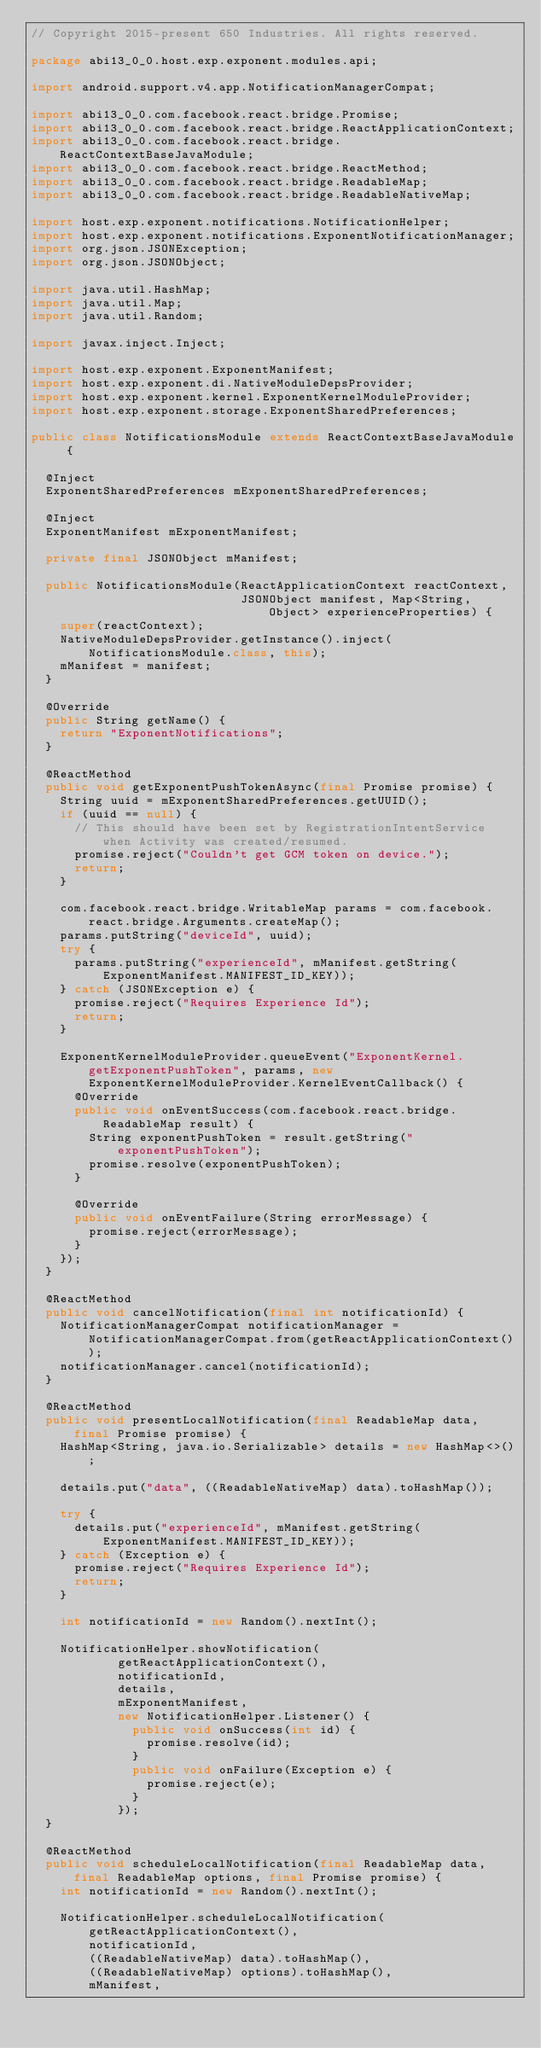Convert code to text. <code><loc_0><loc_0><loc_500><loc_500><_Java_>// Copyright 2015-present 650 Industries. All rights reserved.

package abi13_0_0.host.exp.exponent.modules.api;

import android.support.v4.app.NotificationManagerCompat;

import abi13_0_0.com.facebook.react.bridge.Promise;
import abi13_0_0.com.facebook.react.bridge.ReactApplicationContext;
import abi13_0_0.com.facebook.react.bridge.ReactContextBaseJavaModule;
import abi13_0_0.com.facebook.react.bridge.ReactMethod;
import abi13_0_0.com.facebook.react.bridge.ReadableMap;
import abi13_0_0.com.facebook.react.bridge.ReadableNativeMap;

import host.exp.exponent.notifications.NotificationHelper;
import host.exp.exponent.notifications.ExponentNotificationManager;
import org.json.JSONException;
import org.json.JSONObject;

import java.util.HashMap;
import java.util.Map;
import java.util.Random;

import javax.inject.Inject;

import host.exp.exponent.ExponentManifest;
import host.exp.exponent.di.NativeModuleDepsProvider;
import host.exp.exponent.kernel.ExponentKernelModuleProvider;
import host.exp.exponent.storage.ExponentSharedPreferences;

public class NotificationsModule extends ReactContextBaseJavaModule {

  @Inject
  ExponentSharedPreferences mExponentSharedPreferences;

  @Inject
  ExponentManifest mExponentManifest;

  private final JSONObject mManifest;

  public NotificationsModule(ReactApplicationContext reactContext,
                             JSONObject manifest, Map<String, Object> experienceProperties) {
    super(reactContext);
    NativeModuleDepsProvider.getInstance().inject(NotificationsModule.class, this);
    mManifest = manifest;
  }

  @Override
  public String getName() {
    return "ExponentNotifications";
  }

  @ReactMethod
  public void getExponentPushTokenAsync(final Promise promise) {
    String uuid = mExponentSharedPreferences.getUUID();
    if (uuid == null) {
      // This should have been set by RegistrationIntentService when Activity was created/resumed.
      promise.reject("Couldn't get GCM token on device.");
      return;
    }

    com.facebook.react.bridge.WritableMap params = com.facebook.react.bridge.Arguments.createMap();
    params.putString("deviceId", uuid);
    try {
      params.putString("experienceId", mManifest.getString(ExponentManifest.MANIFEST_ID_KEY));
    } catch (JSONException e) {
      promise.reject("Requires Experience Id");
      return;
    }

    ExponentKernelModuleProvider.queueEvent("ExponentKernel.getExponentPushToken", params, new ExponentKernelModuleProvider.KernelEventCallback() {
      @Override
      public void onEventSuccess(com.facebook.react.bridge.ReadableMap result) {
        String exponentPushToken = result.getString("exponentPushToken");
        promise.resolve(exponentPushToken);
      }

      @Override
      public void onEventFailure(String errorMessage) {
        promise.reject(errorMessage);
      }
    });
  }

  @ReactMethod
  public void cancelNotification(final int notificationId) {
    NotificationManagerCompat notificationManager = NotificationManagerCompat.from(getReactApplicationContext());
    notificationManager.cancel(notificationId);
  }

  @ReactMethod
  public void presentLocalNotification(final ReadableMap data, final Promise promise) {
    HashMap<String, java.io.Serializable> details = new HashMap<>();

    details.put("data", ((ReadableNativeMap) data).toHashMap());

    try {
      details.put("experienceId", mManifest.getString(ExponentManifest.MANIFEST_ID_KEY));
    } catch (Exception e) {
      promise.reject("Requires Experience Id");
      return;
    }

    int notificationId = new Random().nextInt();

    NotificationHelper.showNotification(
            getReactApplicationContext(),
            notificationId,
            details,
            mExponentManifest,
            new NotificationHelper.Listener() {
              public void onSuccess(int id) {
                promise.resolve(id);
              }
              public void onFailure(Exception e) {
                promise.reject(e);
              }
            });
  }

  @ReactMethod
  public void scheduleLocalNotification(final ReadableMap data, final ReadableMap options, final Promise promise) {
    int notificationId = new Random().nextInt();

    NotificationHelper.scheduleLocalNotification(
        getReactApplicationContext(),
        notificationId,
        ((ReadableNativeMap) data).toHashMap(),
        ((ReadableNativeMap) options).toHashMap(),
        mManifest,</code> 